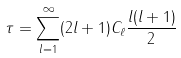Convert formula to latex. <formula><loc_0><loc_0><loc_500><loc_500>\tau = \sum _ { l = 1 } ^ { \infty } ( 2 l + 1 ) C _ { \ell } \frac { l ( l + 1 ) } { 2 }</formula> 